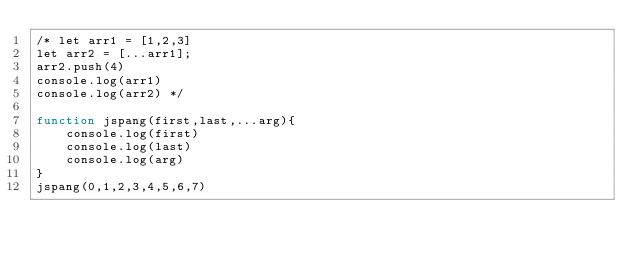<code> <loc_0><loc_0><loc_500><loc_500><_JavaScript_>/* let arr1 = [1,2,3]
let arr2 = [...arr1];
arr2.push(4)
console.log(arr1)
console.log(arr2) */

function jspang(first,last,...arg){
    console.log(first)
    console.log(last)
    console.log(arg)
}
jspang(0,1,2,3,4,5,6,7)</code> 